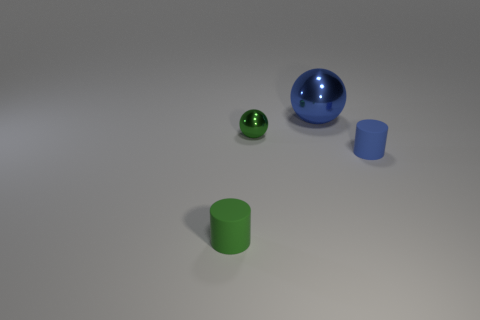There is a small object that is on the left side of the blue matte thing and in front of the green metallic thing; what is its color?
Ensure brevity in your answer.  Green. What is the material of the tiny green cylinder?
Provide a short and direct response. Rubber. There is a blue thing to the right of the big ball; what shape is it?
Keep it short and to the point. Cylinder. There is another cylinder that is the same size as the green cylinder; what is its color?
Make the answer very short. Blue. Does the tiny cylinder that is on the right side of the blue metallic sphere have the same material as the tiny green cylinder?
Provide a succinct answer. Yes. There is a object that is behind the small green matte thing and in front of the green shiny object; what is its size?
Your answer should be compact. Small. There is a matte cylinder that is to the left of the large blue metal thing; what is its size?
Your response must be concise. Small. What is the shape of the other object that is the same color as the big shiny object?
Provide a succinct answer. Cylinder. There is a rubber thing to the left of the blue thing that is to the left of the blue thing to the right of the blue ball; what is its shape?
Your response must be concise. Cylinder. What number of other objects are the same shape as the green rubber thing?
Your answer should be compact. 1. 